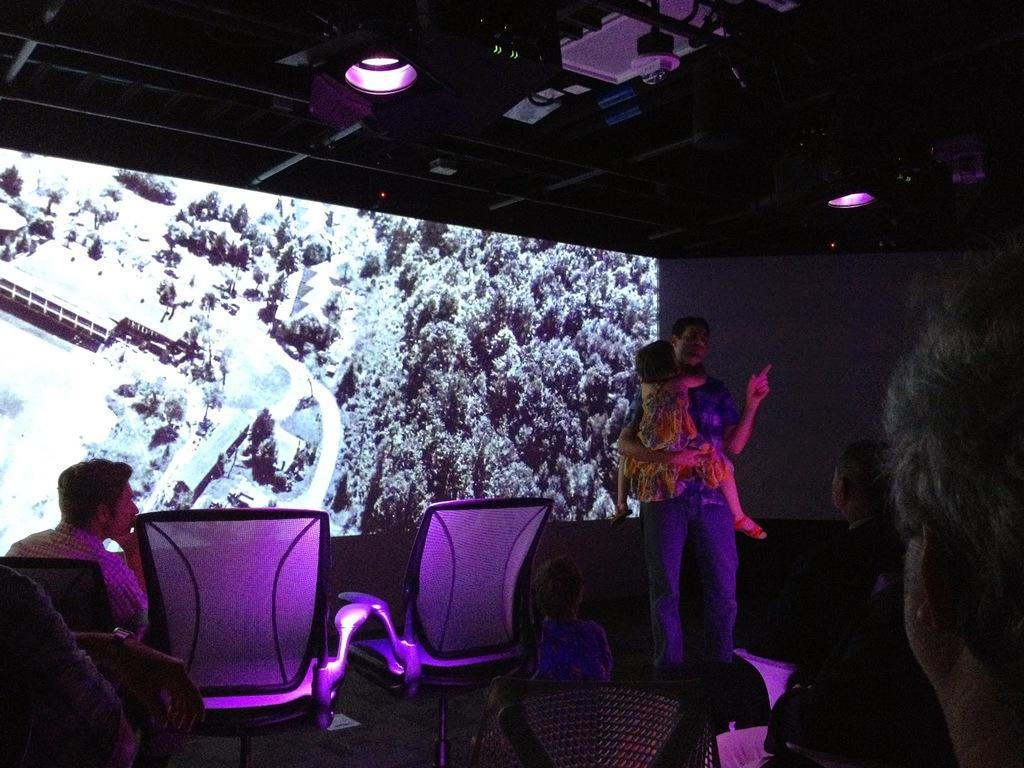How many people are present in the image? There are many people in the image. What can be seen in the image besides the people? There are chairs in the image, and some people are sitting on the chairs. Can you describe the interaction between a person and a child in the image? A person is holding a child in the image. What is visible in the background of the image? There is a screen in the background of the image. What type of lighting is present in the image? There are lights on the ceiling in the image. What type of bears can be seen playing with a board in the image? There are no bears or boards present in the image. How many arms does the person holding the child have in the image? The person holding the child has two arms, as is typical for humans. 